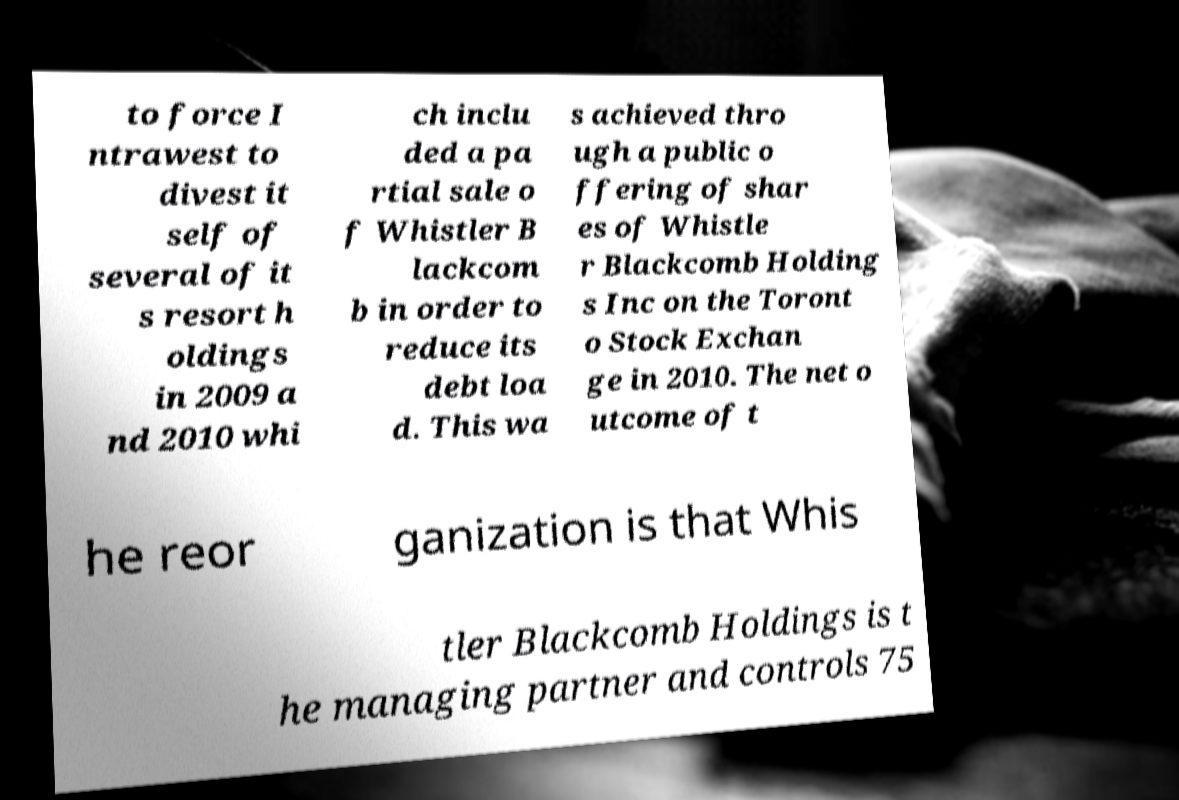Could you extract and type out the text from this image? to force I ntrawest to divest it self of several of it s resort h oldings in 2009 a nd 2010 whi ch inclu ded a pa rtial sale o f Whistler B lackcom b in order to reduce its debt loa d. This wa s achieved thro ugh a public o ffering of shar es of Whistle r Blackcomb Holding s Inc on the Toront o Stock Exchan ge in 2010. The net o utcome of t he reor ganization is that Whis tler Blackcomb Holdings is t he managing partner and controls 75 